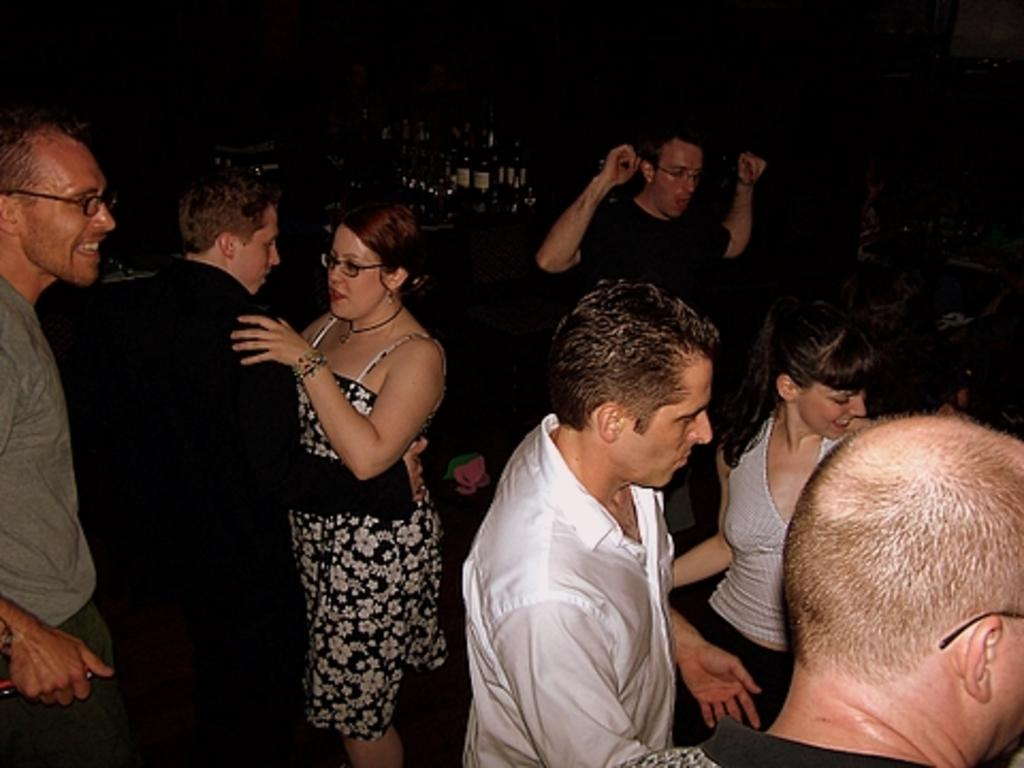How many people are in the image? There is a group of people in the image, but the exact number is not specified. What can be seen in the background of the image? The background of the image is dark, and there is a table in the background. What is on the table in the image? There are bottles on the table in the image. What type of pickle is being discussed by the group of people in the image? There is no indication in the image that the group of people is discussing pickles or any other specific topic. 